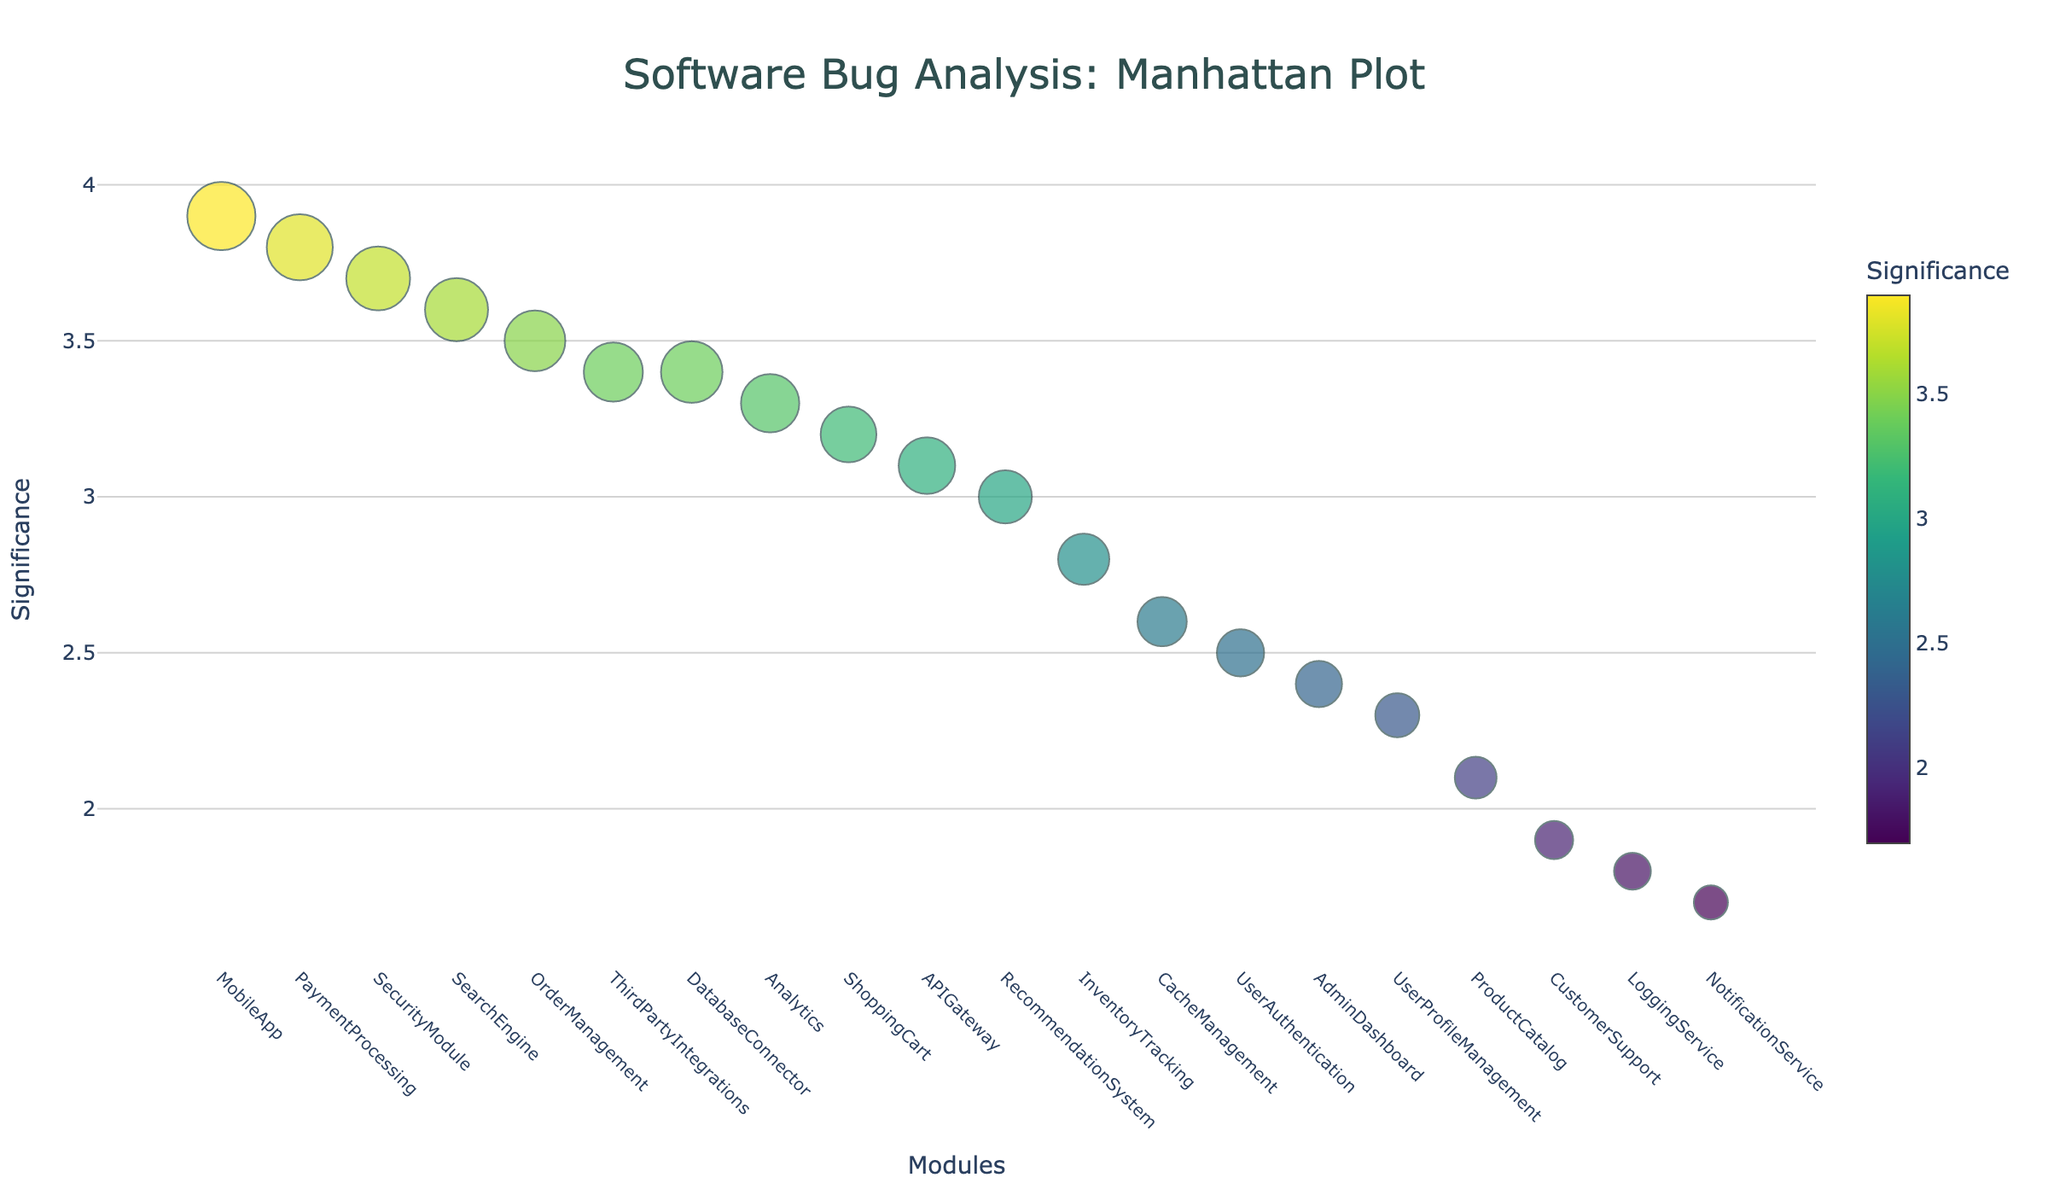How many modules are analyzed in this plot? Count the number of distinct data points on the x-axis (one for each module).
Answer: 18 What is the title of the figure? The title is usually displayed at the top of the plot.
Answer: Software Bug Analysis: Manhattan Plot Which module has the highest significance? Look for the data point with the highest y-axis value (Significance).
Answer: MobileApp Which module has the largest number of bugs? Visualize the data point with the largest marker size, indicating the highest BugCount.
Answer: MobileApp How does the Bug Count compare between 'PaymentProcessing' and 'SearchEngine'? Check the marker size of both data points and compare the numbers in the hover text or legend.
Answer: PaymentProcessing has a higher Bug Count than SearchEngine What is the difference in significance between the 'UserAuthentication' and 'AdminDashboard' modules? Find the significance values of both modules and subtract one from the other: Significance of UserAuthentication (2.5) - Significance of AdminDashboard (2.4).
Answer: 0.1 Which module has the lowest significance while still having a Bug Count greater than 20? First, filter modules by counting those with Bug Count > 20, then look for the one with the lowest significance value.
Answer: CacheManagement Is there a correlation between the BugCount and Significance? Observe the plot to see if larger markers (indicating higher BugCount) consistently align with higher y-axis values (indicating higher Significance).
Answer: Yes, they generally do, indicating a correlation What is the average significance of the modules with a Bug Count higher than 35? Calculate the average of the significance values for modules that fit the condition: PaymentProcessing (3.8), OrderManagement (3.5), SearchEngine (3.6), MobileApp (3.9), DatabaseConnector (3.4). ((3.8 + 3.5 + 3.6 + 3.9 + 3.4) / 5).
Answer: 3.64 Which module has more significance, 'CacheManagement' or 'ThirdPartyIntegrations'? Compare their y-axis values (Significance) directly.
Answer: ThirdPartyIntegrations 